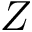<formula> <loc_0><loc_0><loc_500><loc_500>Z</formula> 